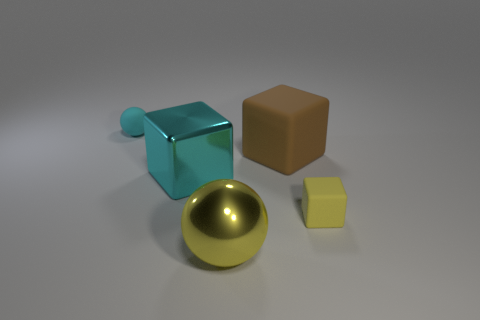How many other objects are the same color as the big ball?
Offer a terse response. 1. There is a block that is the same size as the cyan rubber thing; what is its material?
Provide a short and direct response. Rubber. Are there any other things that are the same size as the yellow ball?
Provide a short and direct response. Yes. How many things are either large matte objects or blocks in front of the brown rubber thing?
Keep it short and to the point. 3. What is the size of the brown thing that is made of the same material as the cyan ball?
Offer a very short reply. Large. There is a tiny object in front of the sphere that is left of the large yellow object; what shape is it?
Offer a very short reply. Cube. There is a matte object that is both to the left of the yellow block and to the right of the cyan shiny block; what size is it?
Provide a succinct answer. Large. Is there a small cyan thing that has the same shape as the big brown matte thing?
Ensure brevity in your answer.  No. Are there any other things that are the same shape as the brown matte object?
Offer a terse response. Yes. The small object that is on the left side of the large brown matte cube that is in front of the cyan thing left of the big shiny cube is made of what material?
Provide a short and direct response. Rubber. 